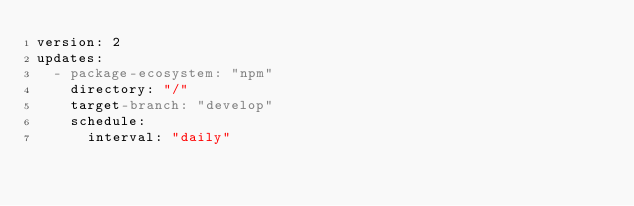<code> <loc_0><loc_0><loc_500><loc_500><_YAML_>version: 2
updates:
  - package-ecosystem: "npm"
    directory: "/"
    target-branch: "develop"
    schedule:
      interval: "daily"
</code> 